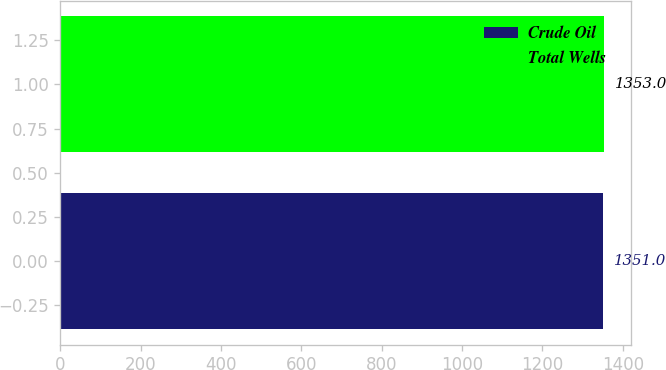Convert chart to OTSL. <chart><loc_0><loc_0><loc_500><loc_500><bar_chart><fcel>Crude Oil<fcel>Total Wells<nl><fcel>1351<fcel>1353<nl></chart> 